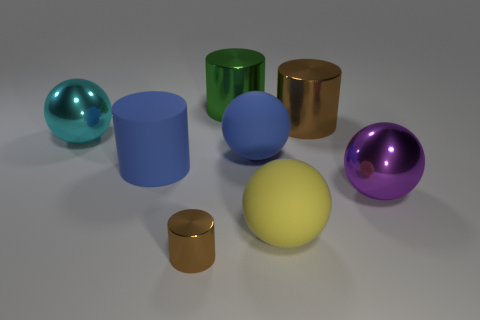How many purple cylinders have the same size as the green cylinder?
Make the answer very short. 0. How many large things are to the left of the green cylinder and in front of the cyan thing?
Your answer should be compact. 1. There is a rubber sphere that is behind the matte cylinder; does it have the same size as the large blue cylinder?
Offer a terse response. Yes. Is there a big ball of the same color as the big matte cylinder?
Give a very brief answer. Yes. There is a ball that is made of the same material as the large purple thing; what size is it?
Provide a short and direct response. Large. Is the number of cyan metal spheres in front of the blue rubber ball greater than the number of large metal cylinders that are in front of the yellow matte object?
Your answer should be very brief. No. How many other objects are there of the same material as the large cyan object?
Provide a succinct answer. 4. Is the big cylinder to the right of the big green thing made of the same material as the big blue ball?
Make the answer very short. No. What is the shape of the green metallic thing?
Give a very brief answer. Cylinder. Are there more cyan metal objects that are to the left of the big blue rubber ball than red metal balls?
Offer a terse response. Yes. 